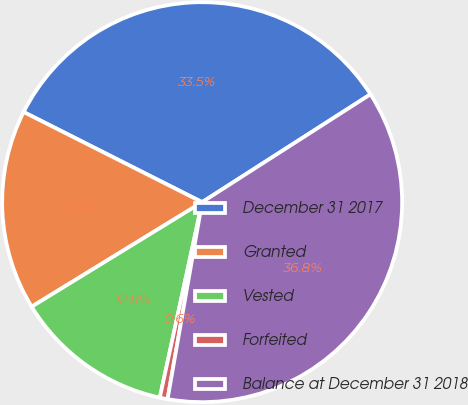<chart> <loc_0><loc_0><loc_500><loc_500><pie_chart><fcel>December 31 2017<fcel>Granted<fcel>Vested<fcel>Forfeited<fcel>Balance at December 31 2018<nl><fcel>33.49%<fcel>16.2%<fcel>12.85%<fcel>0.63%<fcel>36.84%<nl></chart> 